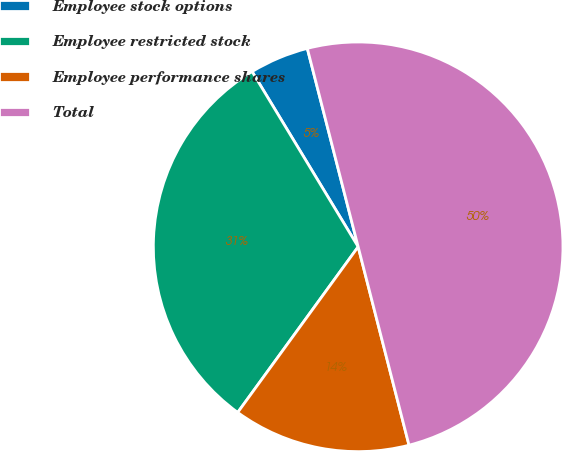<chart> <loc_0><loc_0><loc_500><loc_500><pie_chart><fcel>Employee stock options<fcel>Employee restricted stock<fcel>Employee performance shares<fcel>Total<nl><fcel>4.67%<fcel>31.33%<fcel>14.0%<fcel>50.0%<nl></chart> 